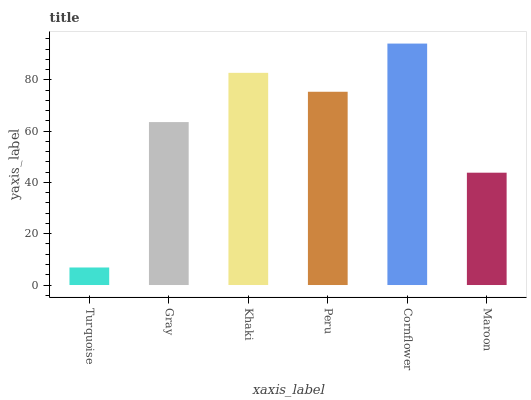Is Gray the minimum?
Answer yes or no. No. Is Gray the maximum?
Answer yes or no. No. Is Gray greater than Turquoise?
Answer yes or no. Yes. Is Turquoise less than Gray?
Answer yes or no. Yes. Is Turquoise greater than Gray?
Answer yes or no. No. Is Gray less than Turquoise?
Answer yes or no. No. Is Peru the high median?
Answer yes or no. Yes. Is Gray the low median?
Answer yes or no. Yes. Is Khaki the high median?
Answer yes or no. No. Is Turquoise the low median?
Answer yes or no. No. 